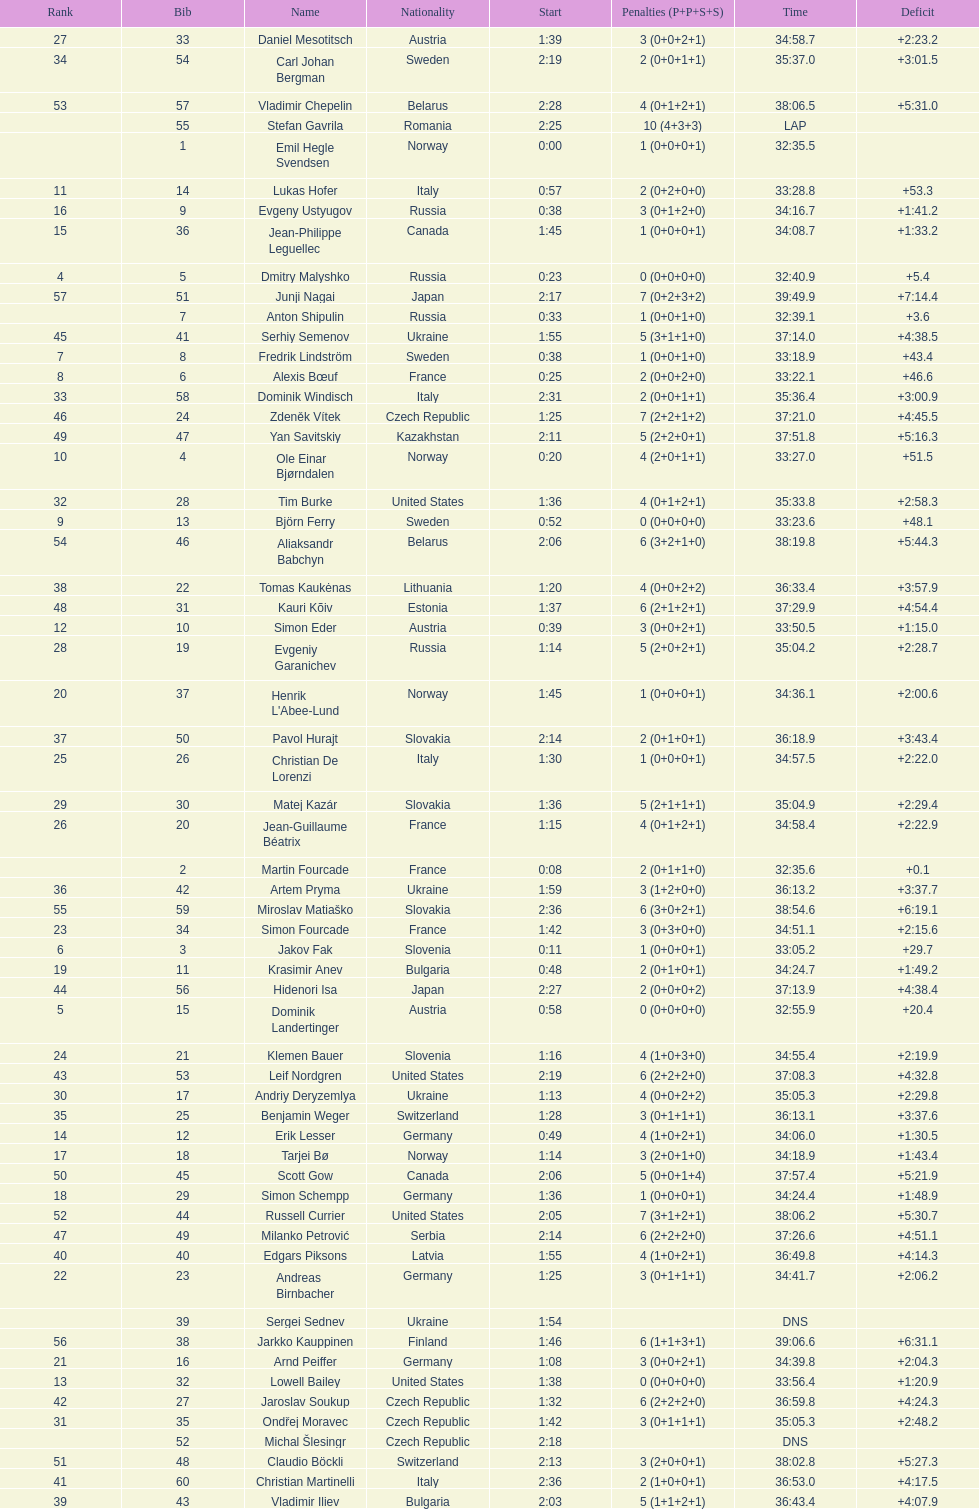Between bjorn ferry, simon elder and erik lesser - who had the most penalties? Erik Lesser. 